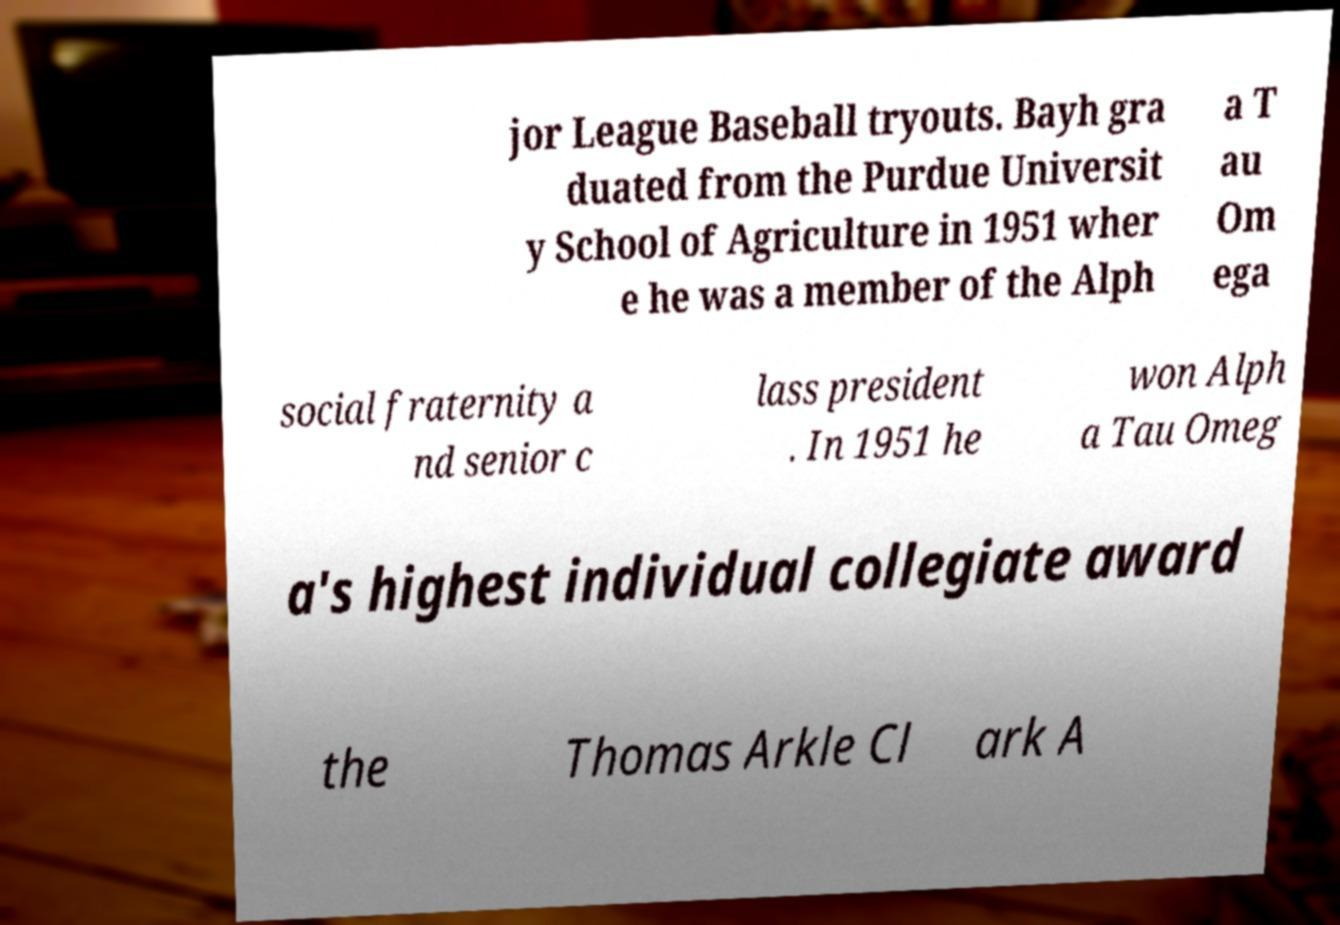Please read and relay the text visible in this image. What does it say? jor League Baseball tryouts. Bayh gra duated from the Purdue Universit y School of Agriculture in 1951 wher e he was a member of the Alph a T au Om ega social fraternity a nd senior c lass president . In 1951 he won Alph a Tau Omeg a's highest individual collegiate award the Thomas Arkle Cl ark A 